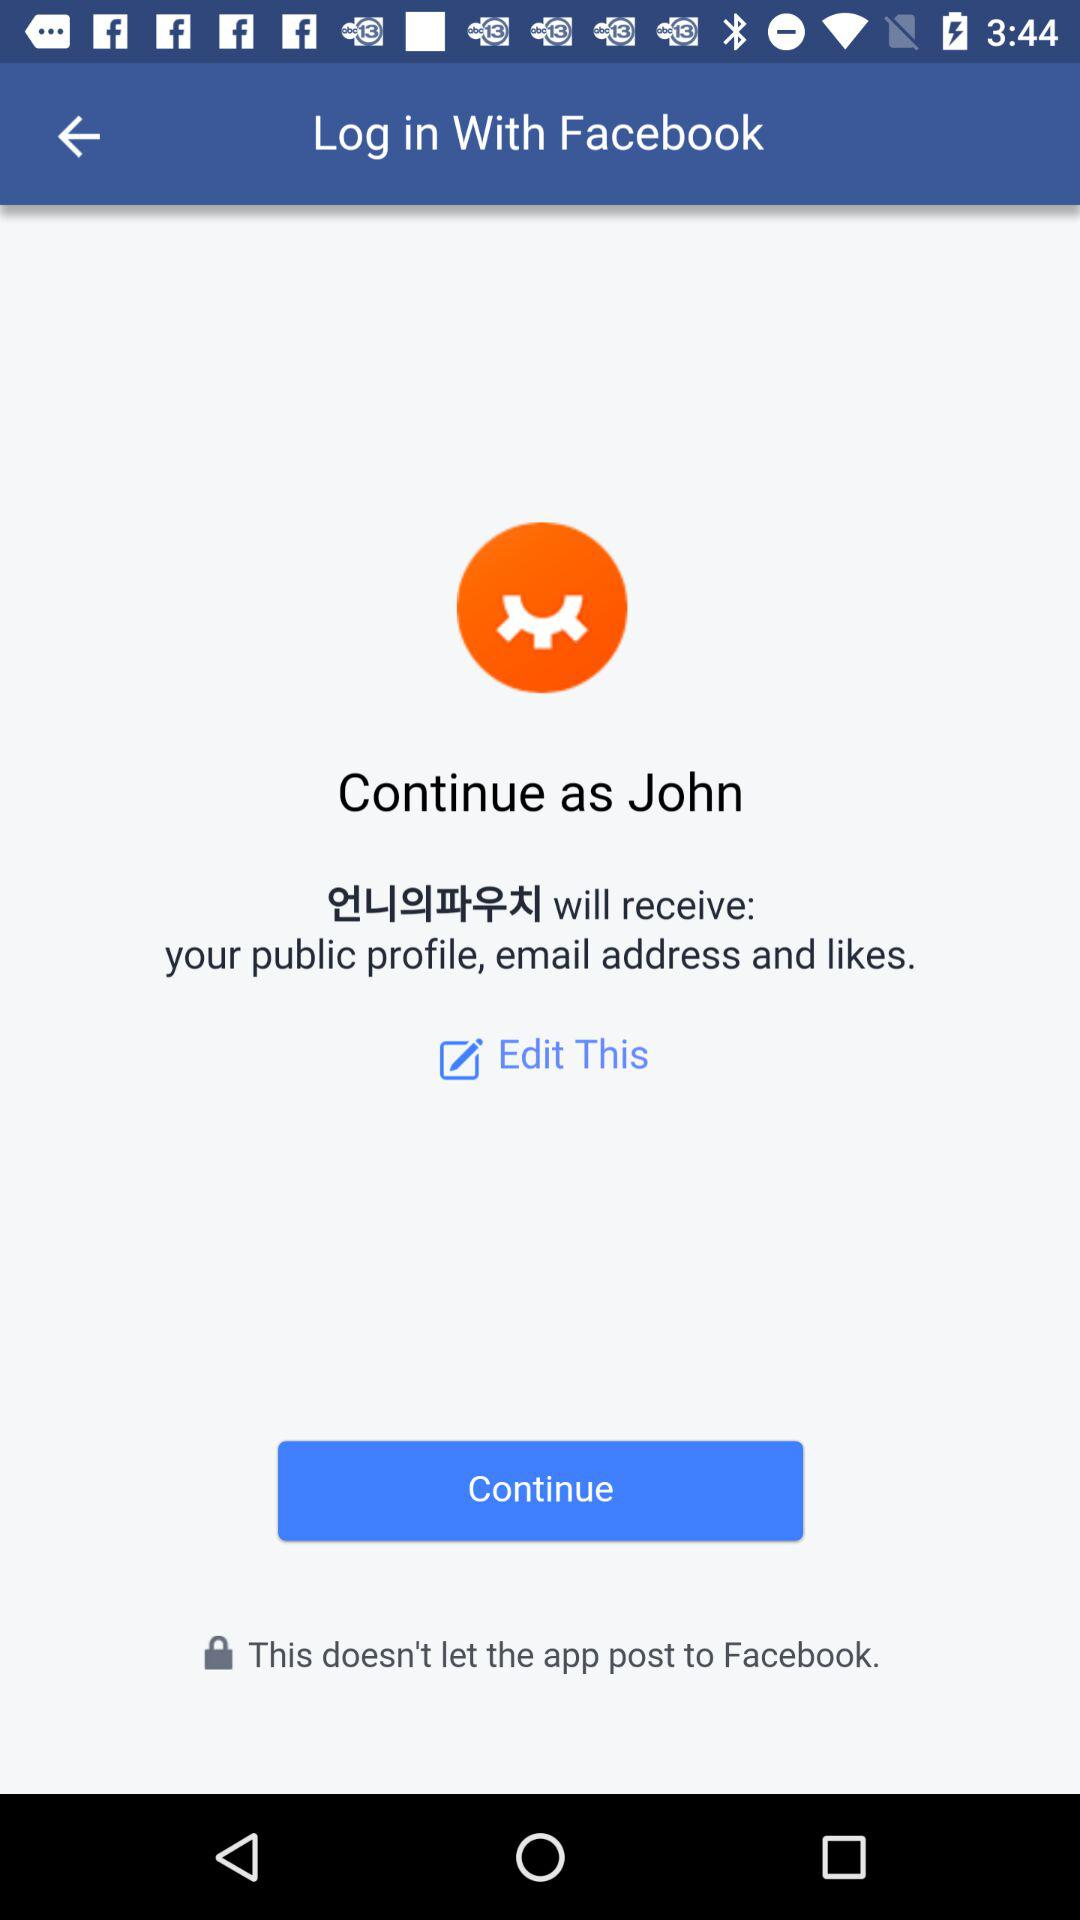What is the user name? The user name is John. 